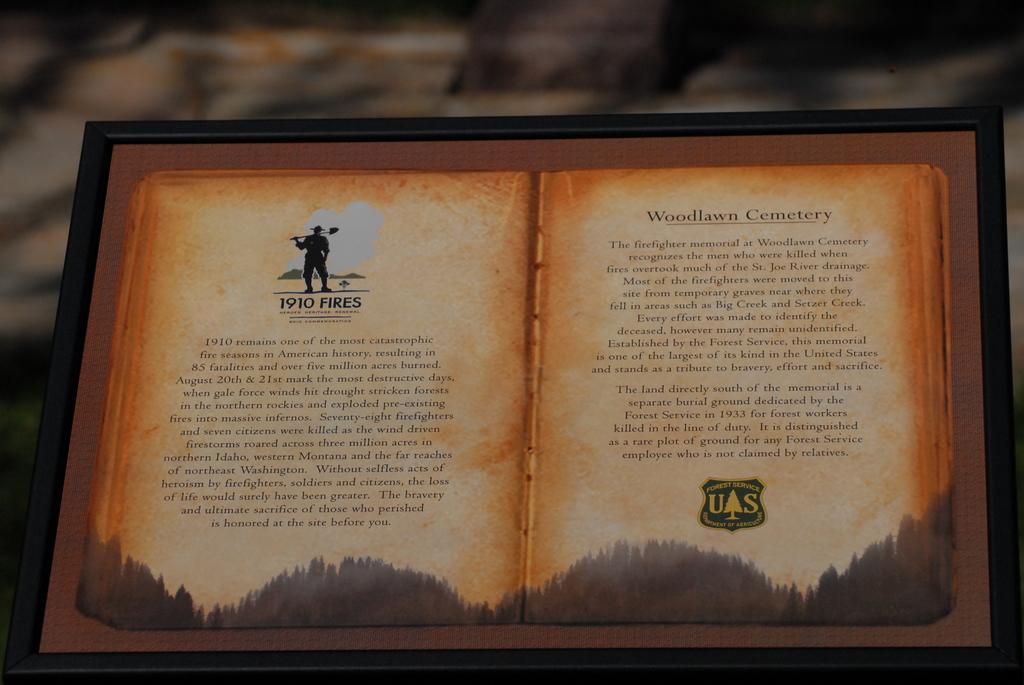What is this book about?
Make the answer very short. 1910 fires. What cemetery is mentioned?
Provide a short and direct response. Woodlawn. 